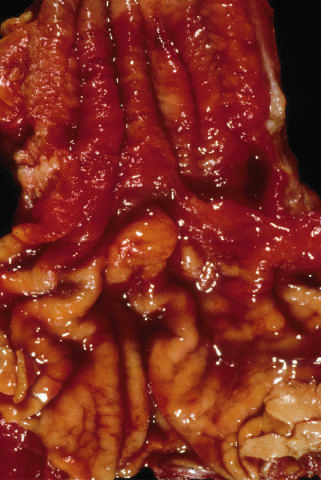what remain within the predominantly metaplastic, reddish mucosa of the distal esophagus?
Answer the question using a single word or phrase. A few areas of pale squamous mucosa 